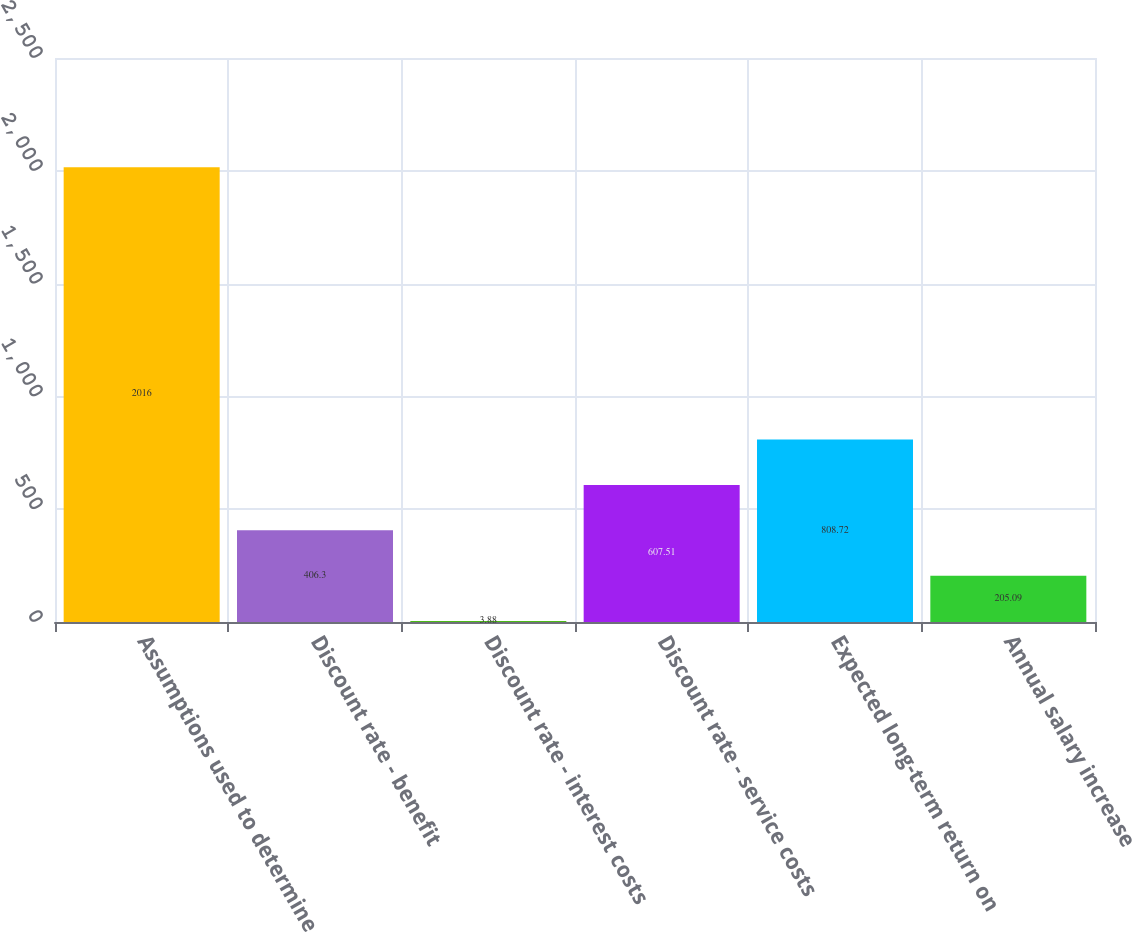Convert chart to OTSL. <chart><loc_0><loc_0><loc_500><loc_500><bar_chart><fcel>Assumptions used to determine<fcel>Discount rate - benefit<fcel>Discount rate - interest costs<fcel>Discount rate - service costs<fcel>Expected long-term return on<fcel>Annual salary increase<nl><fcel>2016<fcel>406.3<fcel>3.88<fcel>607.51<fcel>808.72<fcel>205.09<nl></chart> 